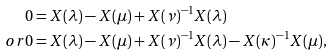Convert formula to latex. <formula><loc_0><loc_0><loc_500><loc_500>0 & = X ( \lambda ) - X ( \mu ) + X ( \nu ) ^ { - 1 } X ( \lambda ) \\ o r 0 & = X ( \lambda ) - X ( \mu ) + X ( \nu ) ^ { - 1 } X ( \lambda ) - X ( \kappa ) ^ { - 1 } X ( \mu ) ,</formula> 